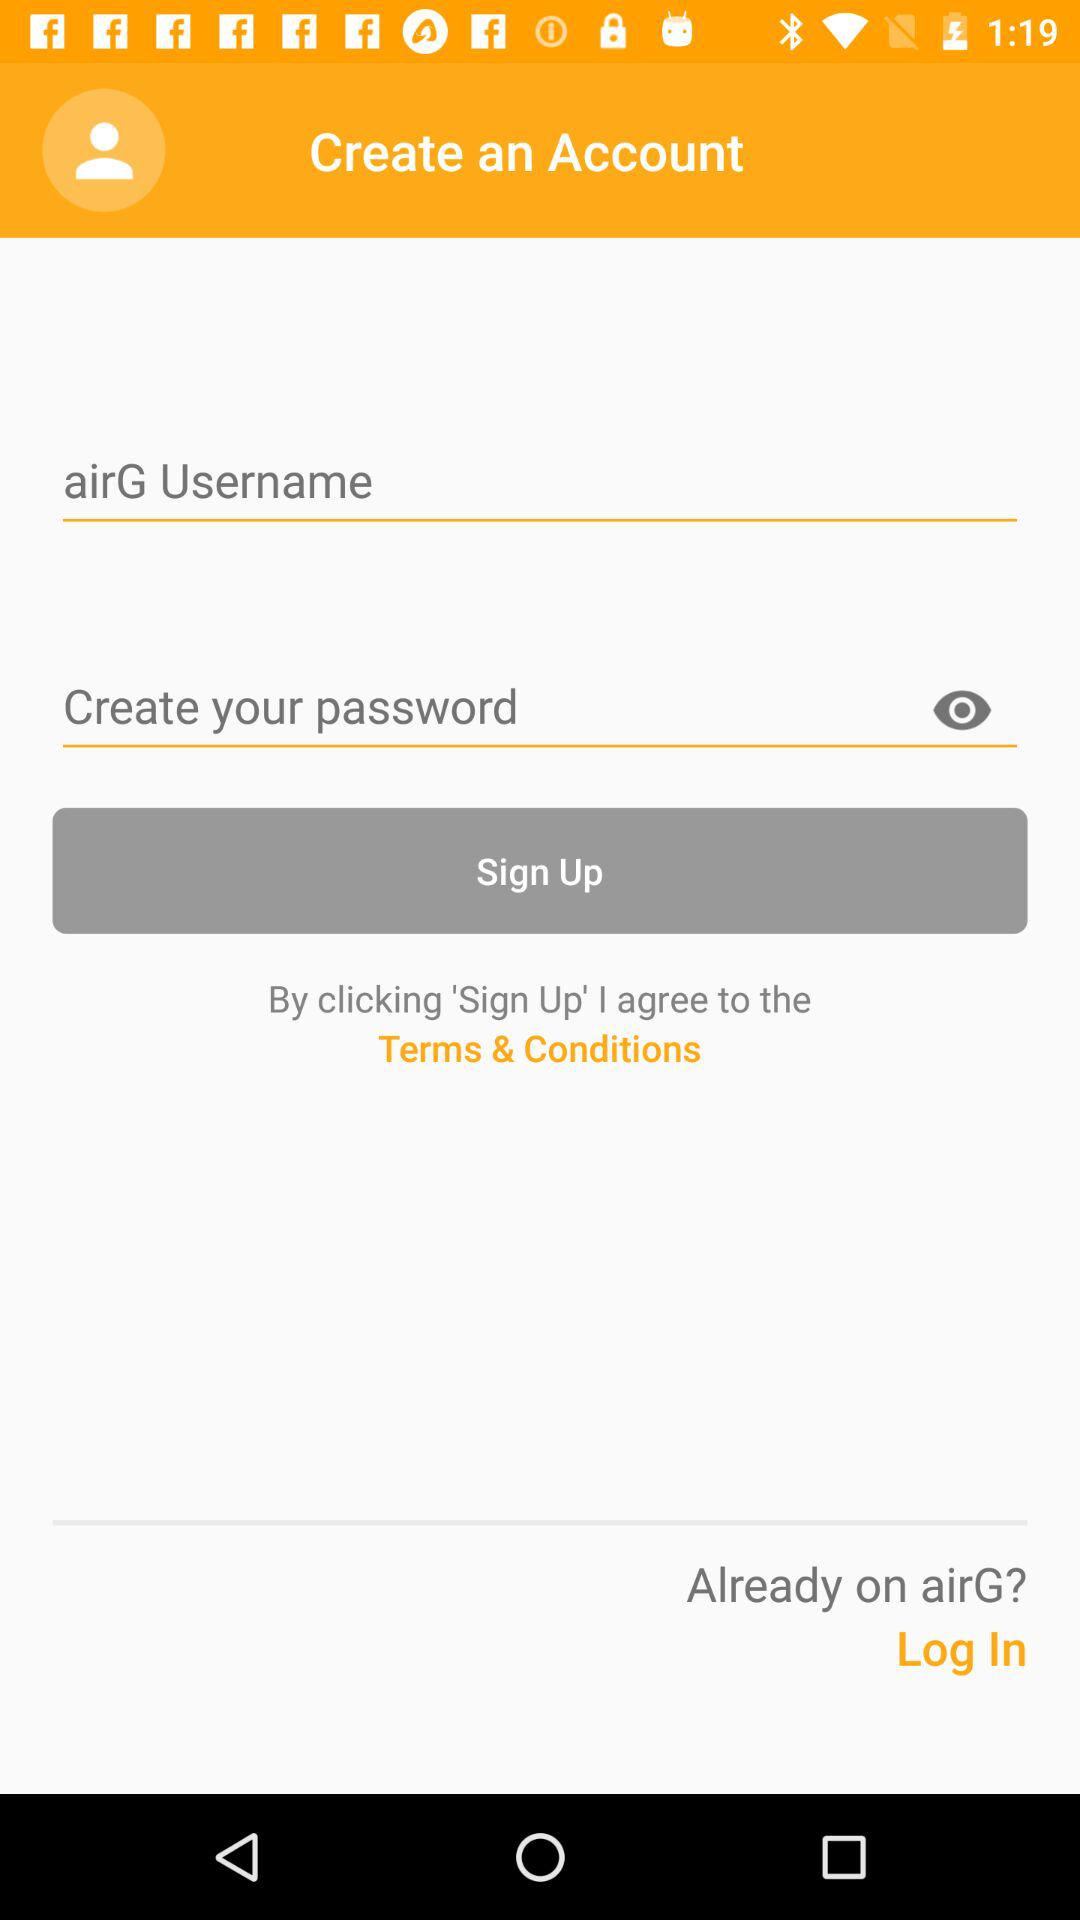What is the application name? The application name is "airG". 